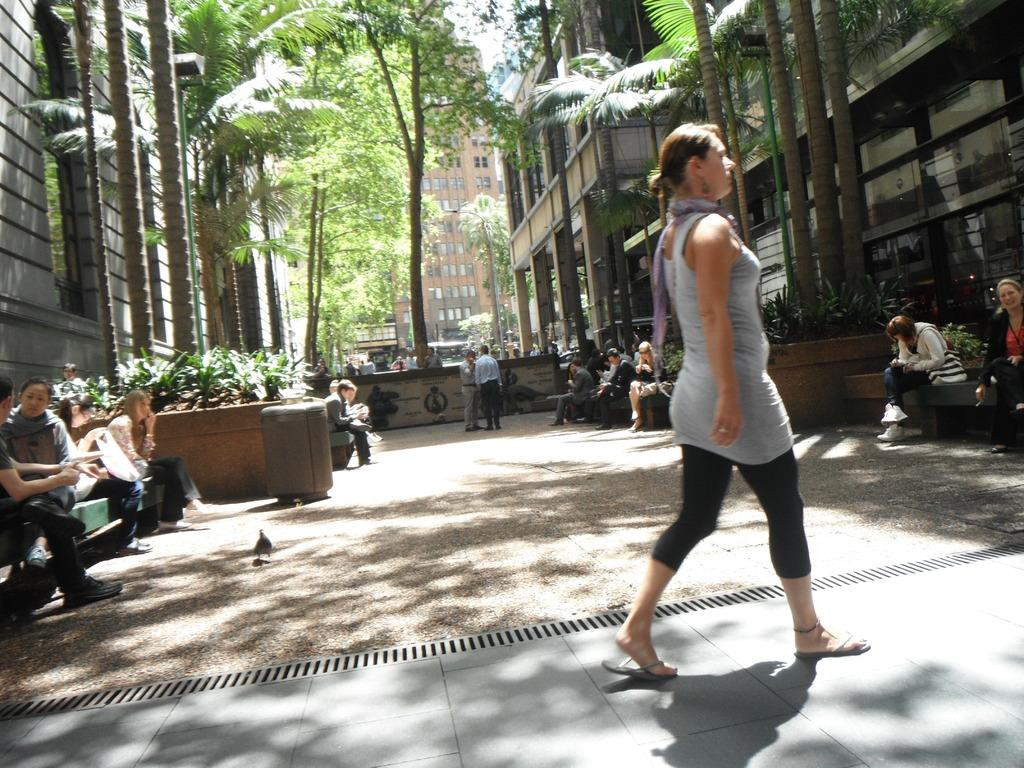What type of structures can be seen in the image? There are buildings in the image. What other natural elements are present in the image? There are trees in the image. What are some people doing in the image? There are people sitting on staircases and people walking in the image. How many bushes can be seen in the image? There are no bushes mentioned or visible in the image. Can you hear the people in the image laughing? The image is a still picture, so there is no sound or indication of laughter. 